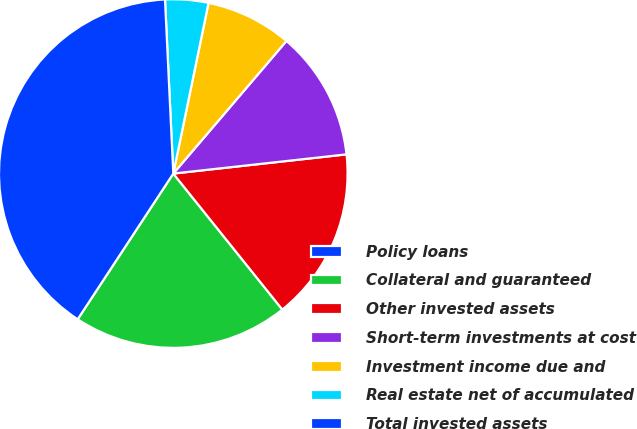<chart> <loc_0><loc_0><loc_500><loc_500><pie_chart><fcel>Policy loans<fcel>Collateral and guaranteed<fcel>Other invested assets<fcel>Short-term investments at cost<fcel>Investment income due and<fcel>Real estate net of accumulated<fcel>Total invested assets<nl><fcel>0.0%<fcel>20.0%<fcel>16.0%<fcel>12.0%<fcel>8.0%<fcel>4.0%<fcel>40.0%<nl></chart> 